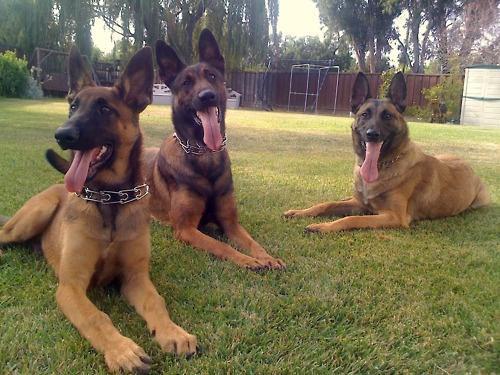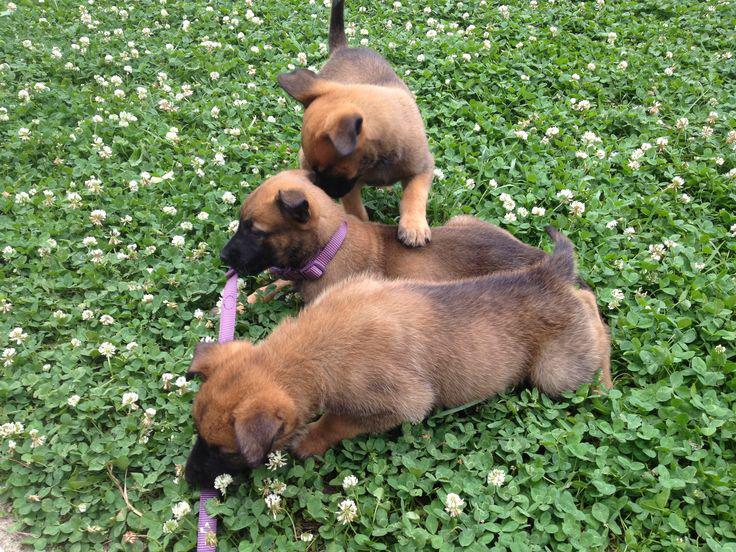The first image is the image on the left, the second image is the image on the right. Given the left and right images, does the statement "There is exactly three dogs in the left image." hold true? Answer yes or no. Yes. The first image is the image on the left, the second image is the image on the right. Examine the images to the left and right. Is the description "Every photograph shows exactly three German Shepard dogs photographed outside, with at least two dogs on the left hand side sticking their tongues out." accurate? Answer yes or no. Yes. 